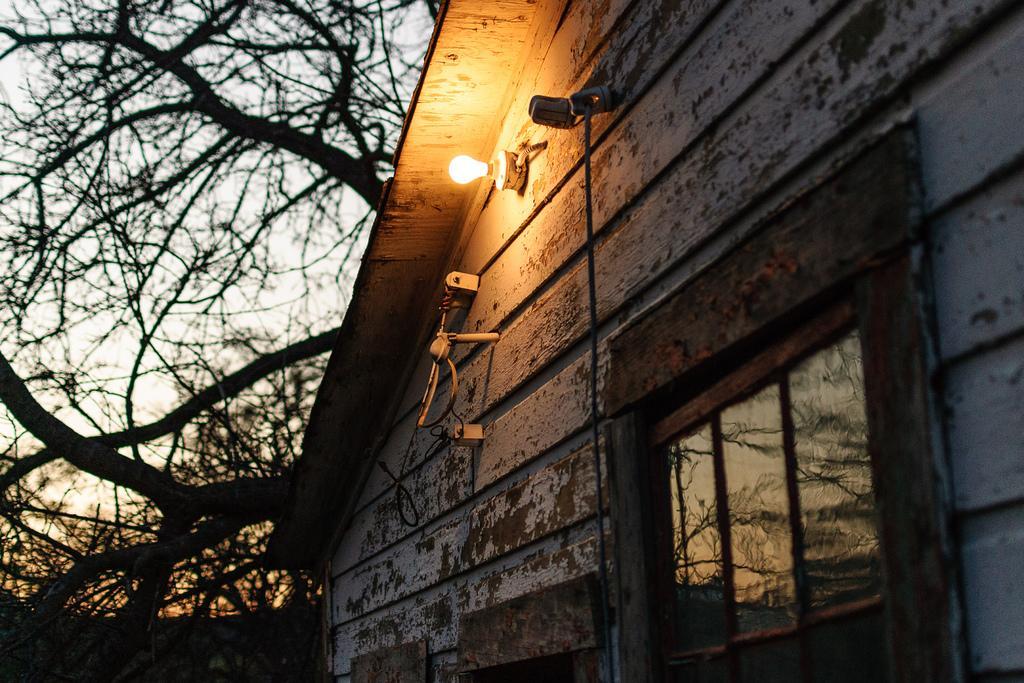Please provide a concise description of this image. This is a picture of a house. On the right there is a window. In the center there are bulb, cable and some other objects. In the background there are trees. In the foreground it is well. 